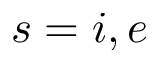Convert formula to latex. <formula><loc_0><loc_0><loc_500><loc_500>s = i , e</formula> 